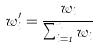Convert formula to latex. <formula><loc_0><loc_0><loc_500><loc_500>w _ { i } ^ { \prime } = \frac { w _ { i } } { \sum _ { i = 1 } ^ { n } w _ { i } }</formula> 